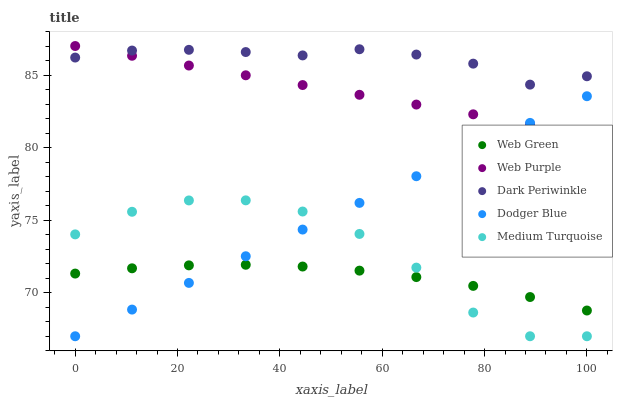Does Web Green have the minimum area under the curve?
Answer yes or no. Yes. Does Dark Periwinkle have the maximum area under the curve?
Answer yes or no. Yes. Does Dodger Blue have the minimum area under the curve?
Answer yes or no. No. Does Dodger Blue have the maximum area under the curve?
Answer yes or no. No. Is Dodger Blue the smoothest?
Answer yes or no. Yes. Is Medium Turquoise the roughest?
Answer yes or no. Yes. Is Dark Periwinkle the smoothest?
Answer yes or no. No. Is Dark Periwinkle the roughest?
Answer yes or no. No. Does Dodger Blue have the lowest value?
Answer yes or no. Yes. Does Dark Periwinkle have the lowest value?
Answer yes or no. No. Does Web Purple have the highest value?
Answer yes or no. Yes. Does Dodger Blue have the highest value?
Answer yes or no. No. Is Medium Turquoise less than Dark Periwinkle?
Answer yes or no. Yes. Is Dark Periwinkle greater than Web Green?
Answer yes or no. Yes. Does Web Purple intersect Dark Periwinkle?
Answer yes or no. Yes. Is Web Purple less than Dark Periwinkle?
Answer yes or no. No. Is Web Purple greater than Dark Periwinkle?
Answer yes or no. No. Does Medium Turquoise intersect Dark Periwinkle?
Answer yes or no. No. 